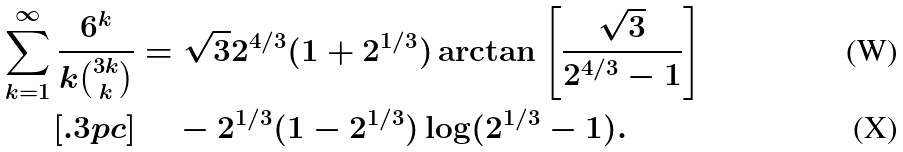Convert formula to latex. <formula><loc_0><loc_0><loc_500><loc_500>\sum _ { k = 1 } ^ { \infty } \frac { 6 ^ { k } } { k \binom { 3 k } { k } } & = \sqrt { 3 } 2 ^ { 4 / 3 } ( 1 + 2 ^ { 1 / 3 } ) \arctan \left [ { \frac { \sqrt { 3 } } { 2 ^ { 4 / 3 } - 1 } } \right ] \\ [ . 3 p c ] & \quad \, - 2 ^ { 1 / 3 } ( 1 - 2 ^ { 1 / 3 } ) \log ( 2 ^ { 1 / 3 } - 1 ) .</formula> 